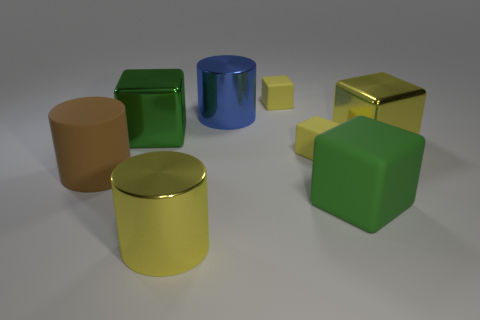Is there anything else that has the same color as the big rubber block?
Your answer should be very brief. Yes. There is a small matte thing behind the big yellow cube; is its shape the same as the big yellow thing that is right of the blue metallic cylinder?
Your response must be concise. Yes. Is there another cube of the same color as the big rubber cube?
Make the answer very short. Yes. Does the cube in front of the rubber cylinder have the same color as the metallic block to the left of the large blue metal thing?
Your answer should be very brief. Yes. Are there any big green metal objects in front of the big blue cylinder?
Your answer should be very brief. Yes. Does the brown object have the same shape as the large blue object?
Provide a succinct answer. Yes. Is the number of yellow matte things that are left of the large blue cylinder the same as the number of big green rubber things that are to the right of the yellow cylinder?
Your answer should be very brief. No. How many other objects are the same material as the large brown cylinder?
Provide a succinct answer. 3. What number of large objects are cyan blocks or brown cylinders?
Give a very brief answer. 1. Are there an equal number of yellow matte objects left of the large yellow cylinder and small green cylinders?
Make the answer very short. Yes. 